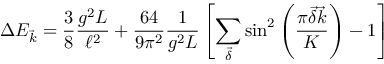Convert formula to latex. <formula><loc_0><loc_0><loc_500><loc_500>\Delta E _ { \vec { k } } = \frac { 3 } { 8 } \frac { g ^ { 2 } L } { \ell ^ { 2 } } + \frac { 6 4 } { 9 \pi ^ { 2 } } \frac { 1 } { g ^ { 2 } L } \left [ \sum _ { \vec { \delta } } \sin ^ { 2 } \left ( \frac { \pi \vec { \delta } \vec { k } } { K } \right ) - 1 \right ]</formula> 